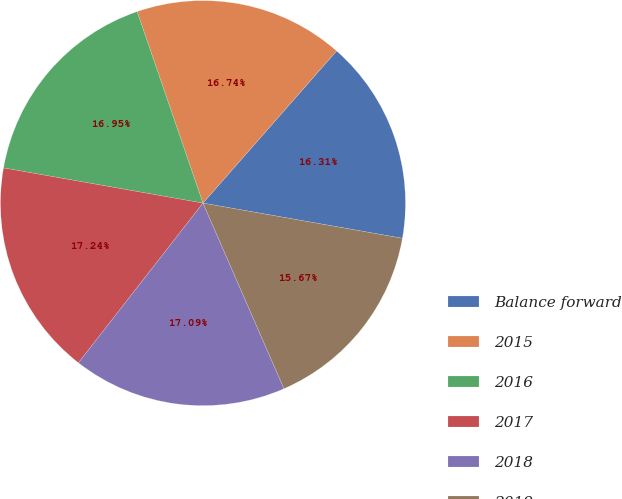<chart> <loc_0><loc_0><loc_500><loc_500><pie_chart><fcel>Balance forward<fcel>2015<fcel>2016<fcel>2017<fcel>2018<fcel>2019<nl><fcel>16.31%<fcel>16.74%<fcel>16.95%<fcel>17.24%<fcel>17.09%<fcel>15.67%<nl></chart> 